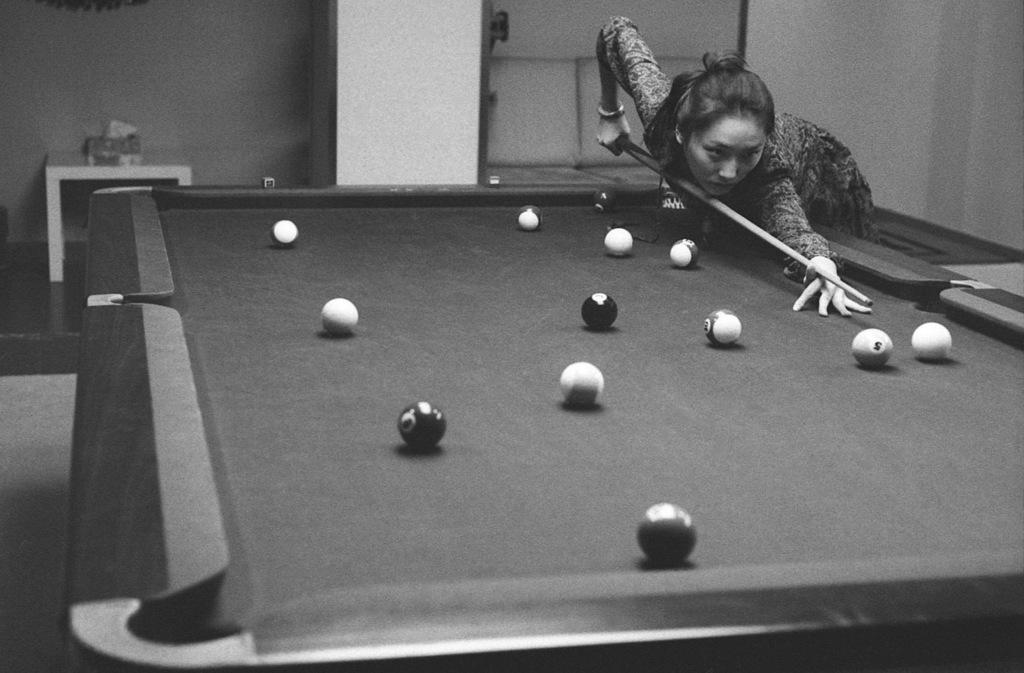What type of table is in the image? There is a snooker table in the image. What is on the snooker table? There are balls on the snooker table. What is the woman in the image doing? The woman is playing with a stick, likely a snooker cue. What can be seen in the background of the image? There is a wall in the background of the image. What type of glue is being used by the woman in the image? There is no glue present in the image; the woman is playing snooker with a cue. How many babies are visible in the image? There are no babies visible in the image. 